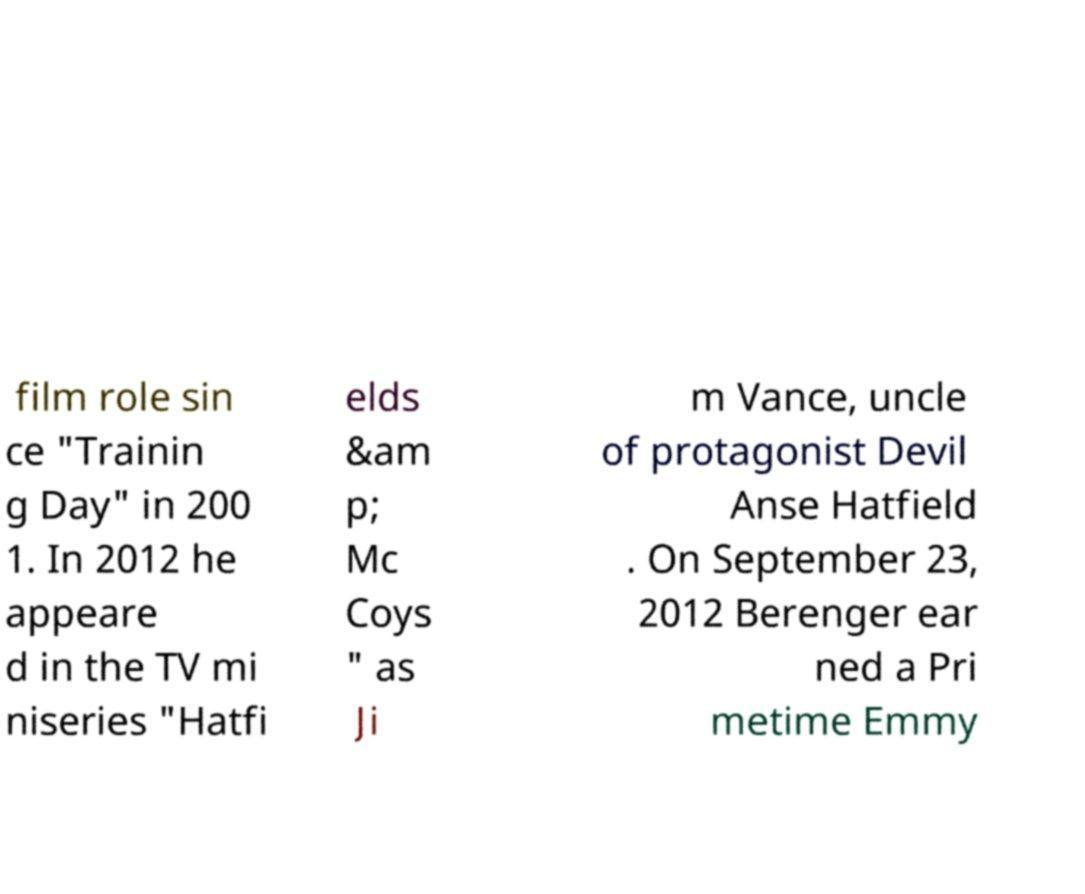Can you accurately transcribe the text from the provided image for me? film role sin ce "Trainin g Day" in 200 1. In 2012 he appeare d in the TV mi niseries "Hatfi elds &am p; Mc Coys " as Ji m Vance, uncle of protagonist Devil Anse Hatfield . On September 23, 2012 Berenger ear ned a Pri metime Emmy 